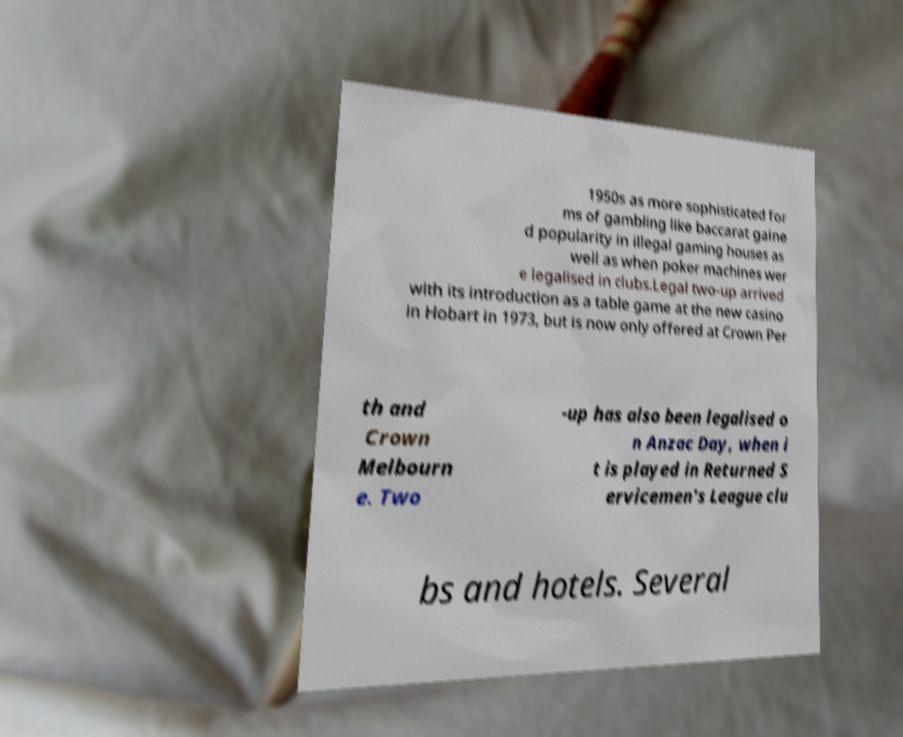Could you extract and type out the text from this image? 1950s as more sophisticated for ms of gambling like baccarat gaine d popularity in illegal gaming houses as well as when poker machines wer e legalised in clubs.Legal two-up arrived with its introduction as a table game at the new casino in Hobart in 1973, but is now only offered at Crown Per th and Crown Melbourn e. Two -up has also been legalised o n Anzac Day, when i t is played in Returned S ervicemen's League clu bs and hotels. Several 